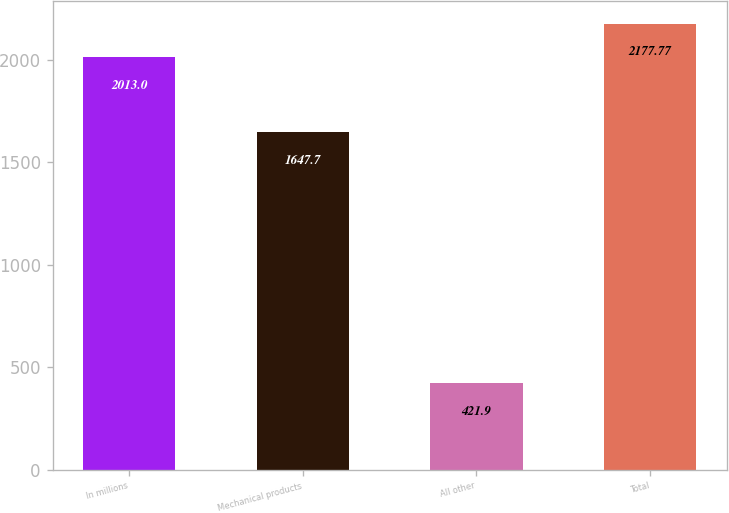Convert chart. <chart><loc_0><loc_0><loc_500><loc_500><bar_chart><fcel>In millions<fcel>Mechanical products<fcel>All other<fcel>Total<nl><fcel>2013<fcel>1647.7<fcel>421.9<fcel>2177.77<nl></chart> 